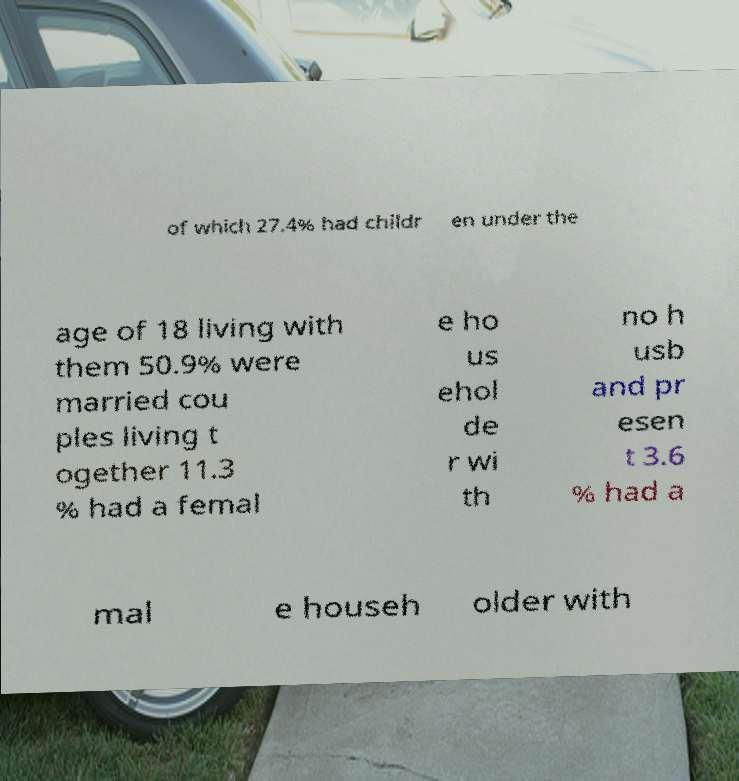There's text embedded in this image that I need extracted. Can you transcribe it verbatim? of which 27.4% had childr en under the age of 18 living with them 50.9% were married cou ples living t ogether 11.3 % had a femal e ho us ehol de r wi th no h usb and pr esen t 3.6 % had a mal e househ older with 